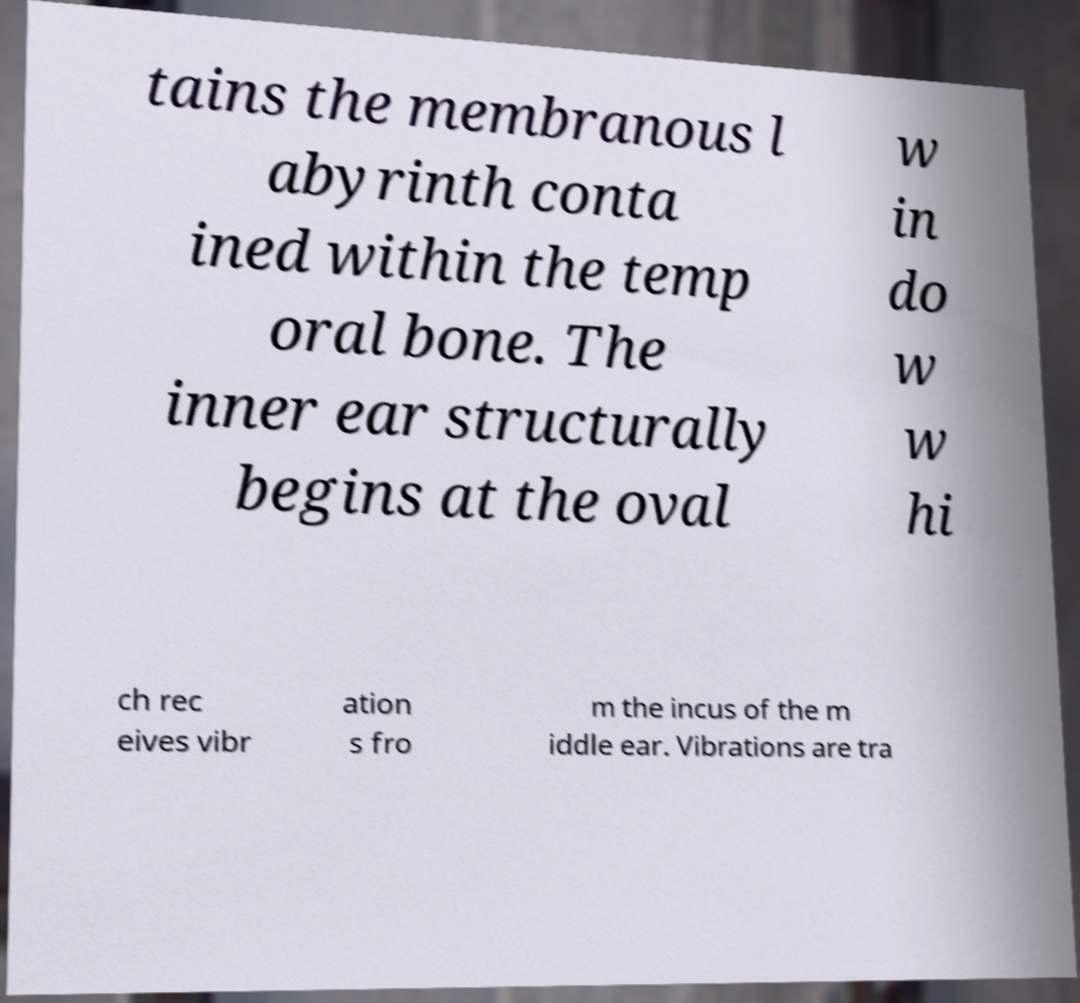There's text embedded in this image that I need extracted. Can you transcribe it verbatim? tains the membranous l abyrinth conta ined within the temp oral bone. The inner ear structurally begins at the oval w in do w w hi ch rec eives vibr ation s fro m the incus of the m iddle ear. Vibrations are tra 